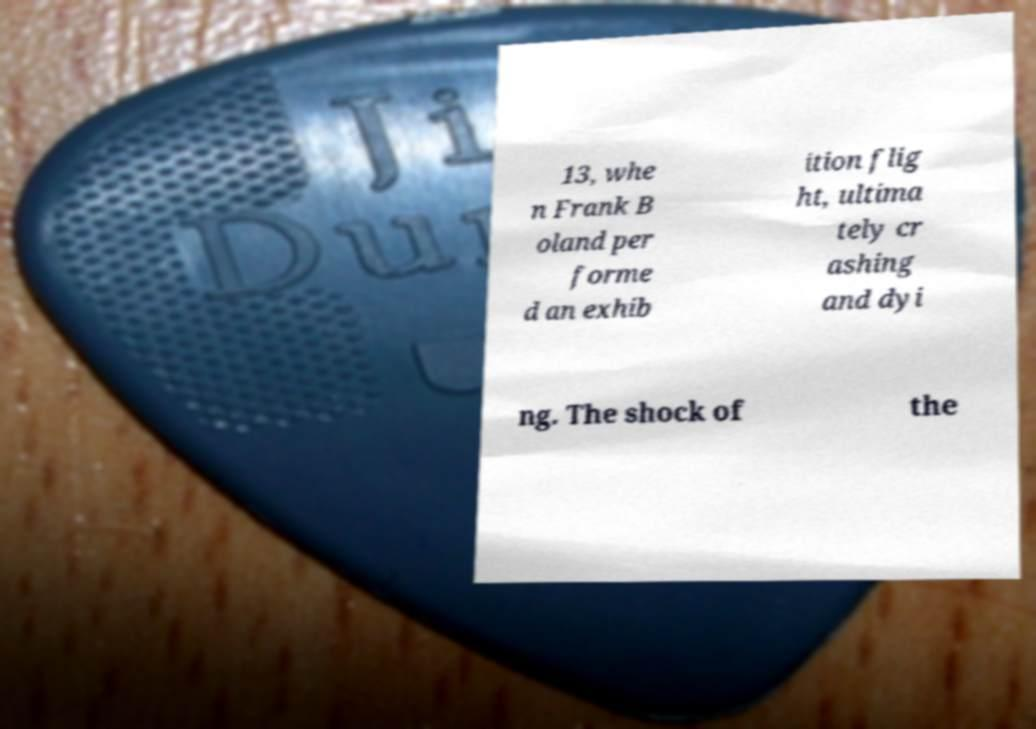Please identify and transcribe the text found in this image. 13, whe n Frank B oland per forme d an exhib ition flig ht, ultima tely cr ashing and dyi ng. The shock of the 